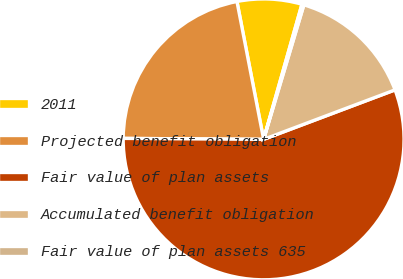Convert chart. <chart><loc_0><loc_0><loc_500><loc_500><pie_chart><fcel>2011<fcel>Projected benefit obligation<fcel>Fair value of plan assets<fcel>Accumulated benefit obligation<fcel>Fair value of plan assets 635<nl><fcel>7.44%<fcel>21.85%<fcel>55.84%<fcel>14.64%<fcel>0.23%<nl></chart> 